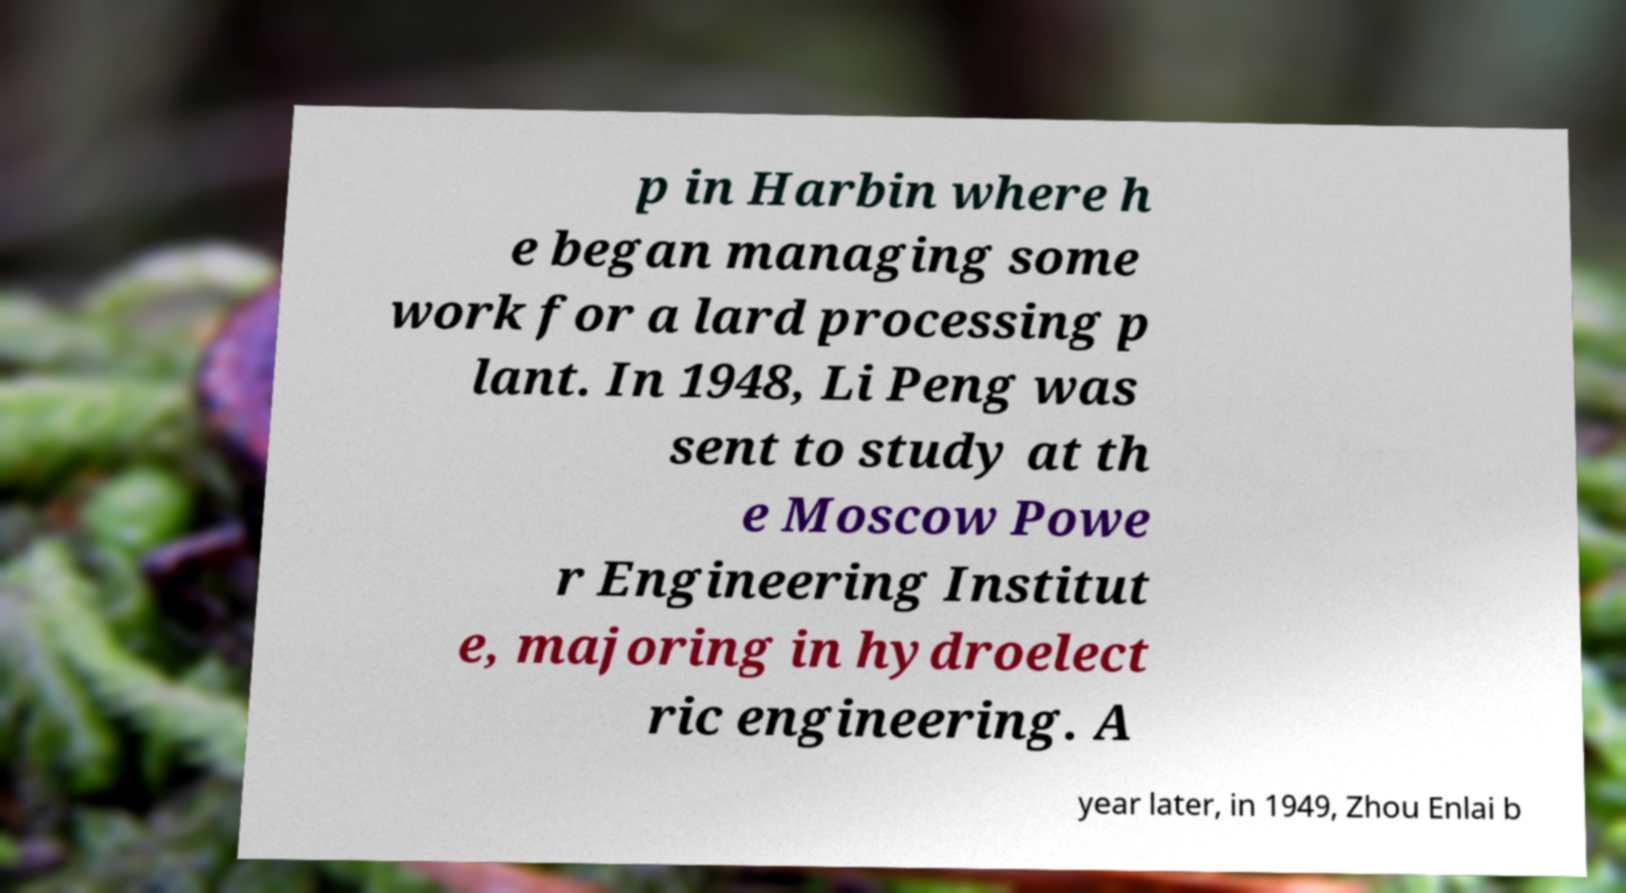Please identify and transcribe the text found in this image. p in Harbin where h e began managing some work for a lard processing p lant. In 1948, Li Peng was sent to study at th e Moscow Powe r Engineering Institut e, majoring in hydroelect ric engineering. A year later, in 1949, Zhou Enlai b 